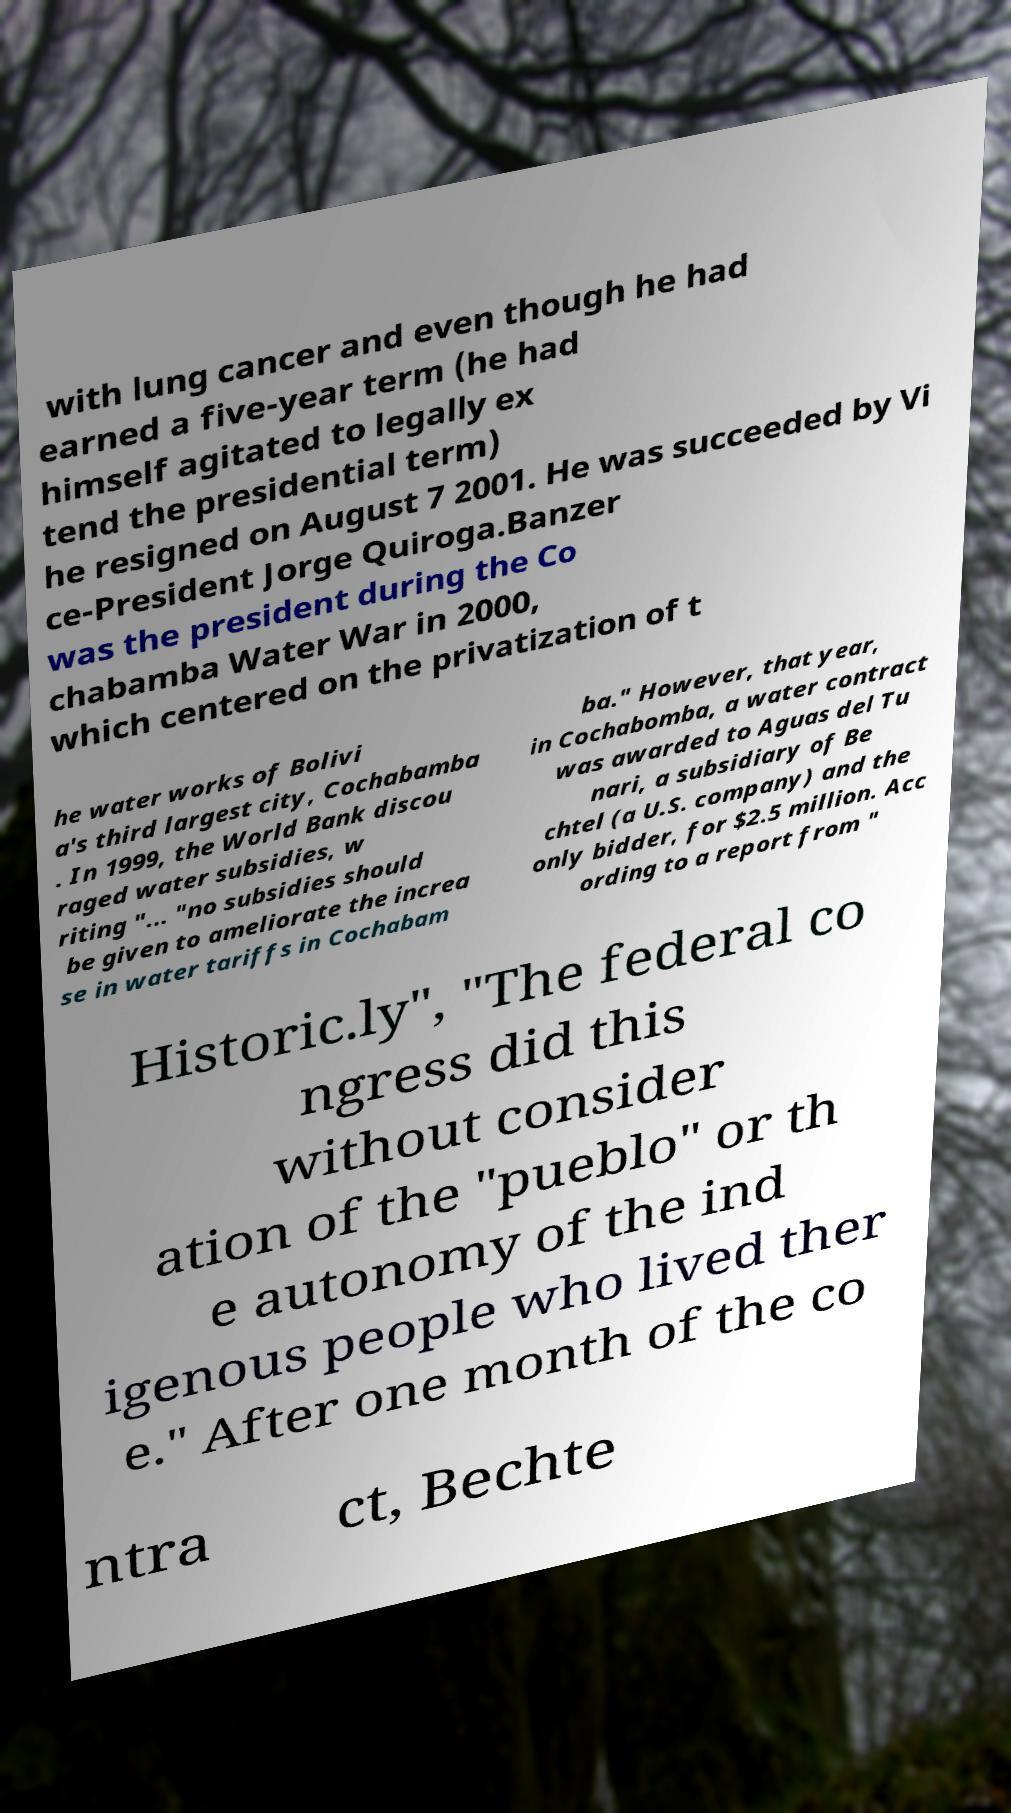Could you extract and type out the text from this image? with lung cancer and even though he had earned a five-year term (he had himself agitated to legally ex tend the presidential term) he resigned on August 7 2001. He was succeeded by Vi ce-President Jorge Quiroga.Banzer was the president during the Co chabamba Water War in 2000, which centered on the privatization of t he water works of Bolivi a's third largest city, Cochabamba . In 1999, the World Bank discou raged water subsidies, w riting "... "no subsidies should be given to ameliorate the increa se in water tariffs in Cochabam ba." However, that year, in Cochabomba, a water contract was awarded to Aguas del Tu nari, a subsidiary of Be chtel (a U.S. company) and the only bidder, for $2.5 million. Acc ording to a report from " Historic.ly", "The federal co ngress did this without consider ation of the "pueblo" or th e autonomy of the ind igenous people who lived ther e." After one month of the co ntra ct, Bechte 